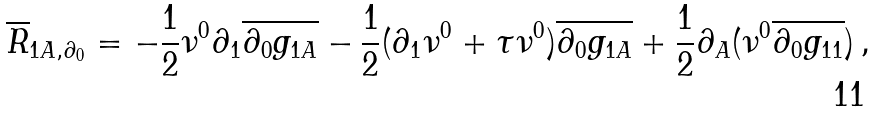<formula> <loc_0><loc_0><loc_500><loc_500>\overline { R } _ { 1 A , \partial _ { 0 } } = - \frac { 1 } { 2 } \nu ^ { 0 } \partial _ { 1 } \overline { \partial _ { 0 } g _ { 1 A } } - \frac { 1 } { 2 } ( \partial _ { 1 } \nu ^ { 0 } + \tau \nu ^ { 0 } ) \overline { \partial _ { 0 } g _ { 1 A } } + \frac { 1 } { 2 } \partial _ { A } ( \nu ^ { 0 } \overline { \partial _ { 0 } g _ { 1 1 } } ) \, ,</formula> 